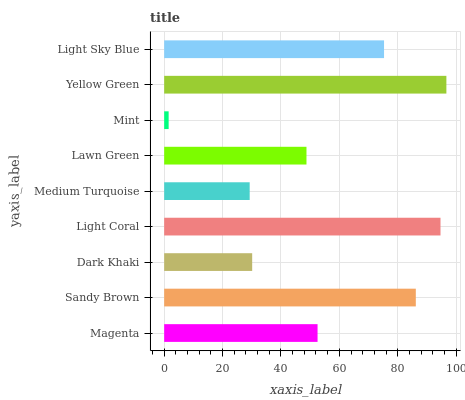Is Mint the minimum?
Answer yes or no. Yes. Is Yellow Green the maximum?
Answer yes or no. Yes. Is Sandy Brown the minimum?
Answer yes or no. No. Is Sandy Brown the maximum?
Answer yes or no. No. Is Sandy Brown greater than Magenta?
Answer yes or no. Yes. Is Magenta less than Sandy Brown?
Answer yes or no. Yes. Is Magenta greater than Sandy Brown?
Answer yes or no. No. Is Sandy Brown less than Magenta?
Answer yes or no. No. Is Magenta the high median?
Answer yes or no. Yes. Is Magenta the low median?
Answer yes or no. Yes. Is Lawn Green the high median?
Answer yes or no. No. Is Sandy Brown the low median?
Answer yes or no. No. 